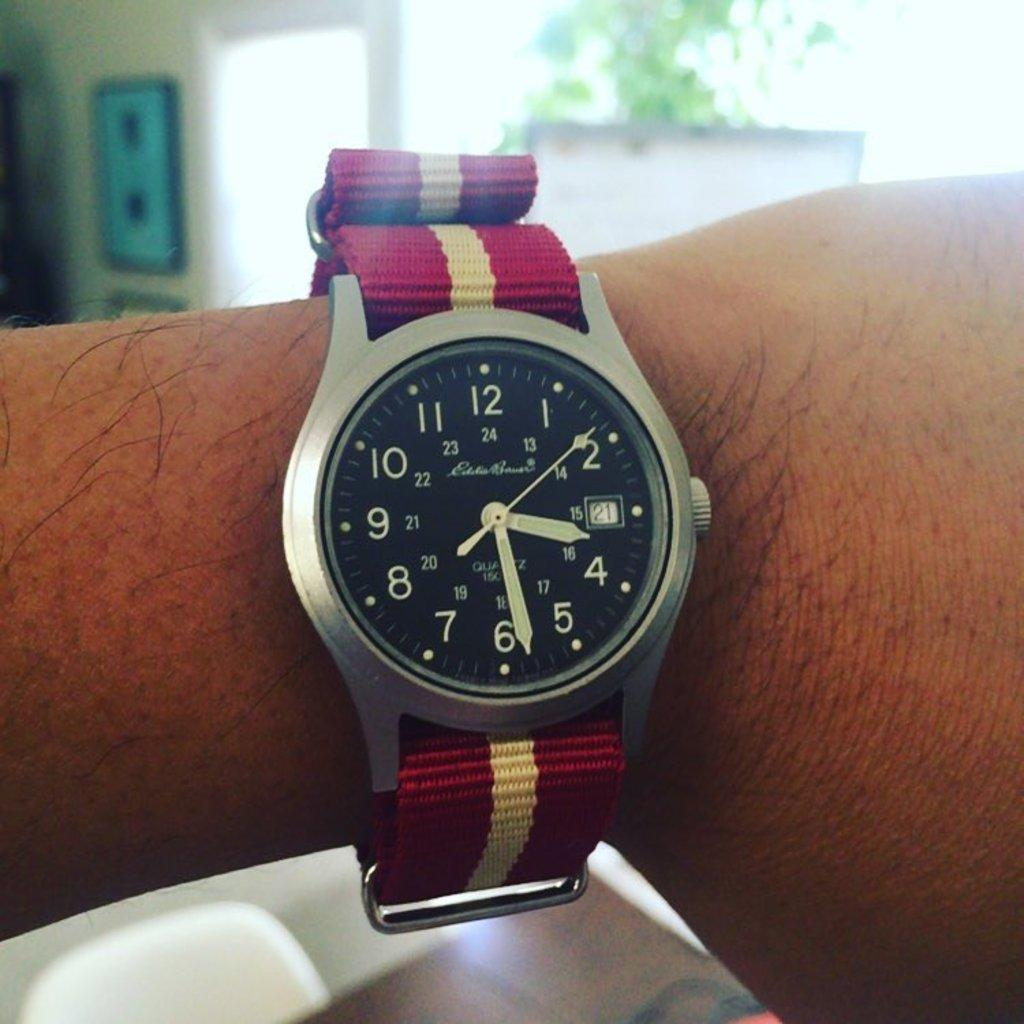<image>
Relay a brief, clear account of the picture shown. Silver and black face of a clock which says the number 24 on the top. 